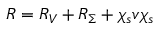Convert formula to latex. <formula><loc_0><loc_0><loc_500><loc_500>R = R _ { V } + R _ { \Sigma } + \chi _ { s } v \chi _ { s }</formula> 